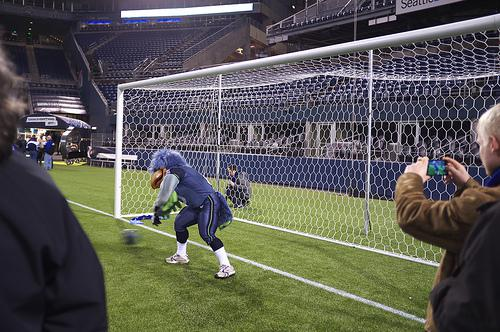Question: when was this photo taken?
Choices:
A. During a game.
B. During a banquet.
C. During a wedding.
D. During a graduation.
Answer with the letter. Answer: A Question: how many people can be seen?
Choices:
A. 4.
B. 3.
C. 6.
D. 5.
Answer with the letter. Answer: D Question: who is taking a photo?
Choices:
A. A girl.
B. A boy.
C. A woman.
D. A man.
Answer with the letter. Answer: D Question: where was this photo taken?
Choices:
A. On a tennis court.
B. On a soccer field.
C. On a golf course.
D. On a baseball field.
Answer with the letter. Answer: B Question: why was this photo taken?
Choices:
A. To show the players.
B. To show what the mascot is doing.
C. To show the fans.
D. To show the umpire.
Answer with the letter. Answer: B Question: what is standing the goal net?
Choices:
A. The referee.
B. The team mascot.
C. The umpire.
D. The ball boy.
Answer with the letter. Answer: B 